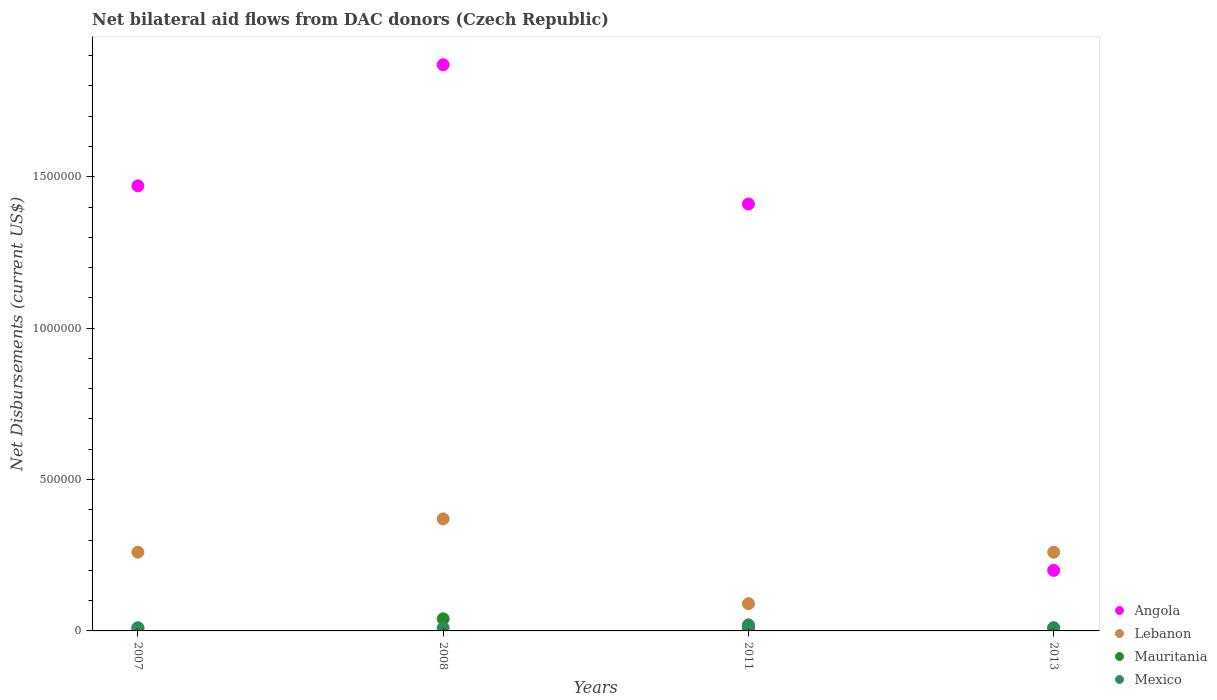Is the number of dotlines equal to the number of legend labels?
Your answer should be very brief. Yes. What is the net bilateral aid flows in Angola in 2008?
Ensure brevity in your answer.  1.87e+06. Across all years, what is the minimum net bilateral aid flows in Lebanon?
Your answer should be compact. 9.00e+04. In which year was the net bilateral aid flows in Mauritania maximum?
Offer a terse response. 2008. What is the total net bilateral aid flows in Lebanon in the graph?
Your answer should be compact. 9.80e+05. What is the difference between the net bilateral aid flows in Lebanon in 2007 and that in 2011?
Provide a short and direct response. 1.70e+05. What is the difference between the net bilateral aid flows in Mauritania in 2011 and the net bilateral aid flows in Lebanon in 2013?
Provide a succinct answer. -2.50e+05. What is the average net bilateral aid flows in Mexico per year?
Give a very brief answer. 1.25e+04. In the year 2008, what is the difference between the net bilateral aid flows in Angola and net bilateral aid flows in Lebanon?
Your answer should be compact. 1.50e+06. What is the ratio of the net bilateral aid flows in Lebanon in 2008 to that in 2013?
Offer a very short reply. 1.42. Is the net bilateral aid flows in Angola in 2007 less than that in 2008?
Make the answer very short. Yes. Is the difference between the net bilateral aid flows in Angola in 2008 and 2011 greater than the difference between the net bilateral aid flows in Lebanon in 2008 and 2011?
Give a very brief answer. Yes. What is the difference between the highest and the lowest net bilateral aid flows in Angola?
Give a very brief answer. 1.67e+06. In how many years, is the net bilateral aid flows in Mexico greater than the average net bilateral aid flows in Mexico taken over all years?
Offer a very short reply. 1. Is the net bilateral aid flows in Mexico strictly greater than the net bilateral aid flows in Mauritania over the years?
Make the answer very short. No. Where does the legend appear in the graph?
Make the answer very short. Bottom right. How are the legend labels stacked?
Give a very brief answer. Vertical. What is the title of the graph?
Provide a short and direct response. Net bilateral aid flows from DAC donors (Czech Republic). Does "Swaziland" appear as one of the legend labels in the graph?
Offer a terse response. No. What is the label or title of the Y-axis?
Offer a very short reply. Net Disbursements (current US$). What is the Net Disbursements (current US$) of Angola in 2007?
Provide a succinct answer. 1.47e+06. What is the Net Disbursements (current US$) in Lebanon in 2007?
Offer a very short reply. 2.60e+05. What is the Net Disbursements (current US$) in Mauritania in 2007?
Ensure brevity in your answer.  10000. What is the Net Disbursements (current US$) of Mexico in 2007?
Provide a short and direct response. 10000. What is the Net Disbursements (current US$) of Angola in 2008?
Offer a terse response. 1.87e+06. What is the Net Disbursements (current US$) in Mauritania in 2008?
Provide a short and direct response. 4.00e+04. What is the Net Disbursements (current US$) in Mexico in 2008?
Your answer should be compact. 10000. What is the Net Disbursements (current US$) of Angola in 2011?
Your response must be concise. 1.41e+06. What is the Net Disbursements (current US$) of Lebanon in 2011?
Give a very brief answer. 9.00e+04. What is the Net Disbursements (current US$) in Mexico in 2011?
Your answer should be compact. 2.00e+04. Across all years, what is the maximum Net Disbursements (current US$) of Angola?
Offer a terse response. 1.87e+06. Across all years, what is the maximum Net Disbursements (current US$) in Lebanon?
Your response must be concise. 3.70e+05. Across all years, what is the minimum Net Disbursements (current US$) in Lebanon?
Ensure brevity in your answer.  9.00e+04. Across all years, what is the minimum Net Disbursements (current US$) in Mauritania?
Your answer should be very brief. 10000. Across all years, what is the minimum Net Disbursements (current US$) in Mexico?
Your response must be concise. 10000. What is the total Net Disbursements (current US$) in Angola in the graph?
Provide a short and direct response. 4.95e+06. What is the total Net Disbursements (current US$) in Lebanon in the graph?
Your answer should be compact. 9.80e+05. What is the total Net Disbursements (current US$) in Mauritania in the graph?
Offer a terse response. 7.00e+04. What is the total Net Disbursements (current US$) in Mexico in the graph?
Your response must be concise. 5.00e+04. What is the difference between the Net Disbursements (current US$) of Angola in 2007 and that in 2008?
Your answer should be very brief. -4.00e+05. What is the difference between the Net Disbursements (current US$) in Lebanon in 2007 and that in 2008?
Your answer should be compact. -1.10e+05. What is the difference between the Net Disbursements (current US$) of Mexico in 2007 and that in 2011?
Provide a short and direct response. -10000. What is the difference between the Net Disbursements (current US$) of Angola in 2007 and that in 2013?
Your answer should be very brief. 1.27e+06. What is the difference between the Net Disbursements (current US$) of Lebanon in 2007 and that in 2013?
Ensure brevity in your answer.  0. What is the difference between the Net Disbursements (current US$) in Lebanon in 2008 and that in 2011?
Give a very brief answer. 2.80e+05. What is the difference between the Net Disbursements (current US$) of Mauritania in 2008 and that in 2011?
Offer a terse response. 3.00e+04. What is the difference between the Net Disbursements (current US$) of Angola in 2008 and that in 2013?
Offer a terse response. 1.67e+06. What is the difference between the Net Disbursements (current US$) of Mauritania in 2008 and that in 2013?
Give a very brief answer. 3.00e+04. What is the difference between the Net Disbursements (current US$) of Angola in 2011 and that in 2013?
Offer a terse response. 1.21e+06. What is the difference between the Net Disbursements (current US$) of Lebanon in 2011 and that in 2013?
Ensure brevity in your answer.  -1.70e+05. What is the difference between the Net Disbursements (current US$) in Mauritania in 2011 and that in 2013?
Offer a terse response. 0. What is the difference between the Net Disbursements (current US$) in Mexico in 2011 and that in 2013?
Keep it short and to the point. 10000. What is the difference between the Net Disbursements (current US$) in Angola in 2007 and the Net Disbursements (current US$) in Lebanon in 2008?
Provide a succinct answer. 1.10e+06. What is the difference between the Net Disbursements (current US$) of Angola in 2007 and the Net Disbursements (current US$) of Mauritania in 2008?
Your answer should be compact. 1.43e+06. What is the difference between the Net Disbursements (current US$) of Angola in 2007 and the Net Disbursements (current US$) of Mexico in 2008?
Your answer should be compact. 1.46e+06. What is the difference between the Net Disbursements (current US$) of Lebanon in 2007 and the Net Disbursements (current US$) of Mauritania in 2008?
Give a very brief answer. 2.20e+05. What is the difference between the Net Disbursements (current US$) in Lebanon in 2007 and the Net Disbursements (current US$) in Mexico in 2008?
Keep it short and to the point. 2.50e+05. What is the difference between the Net Disbursements (current US$) in Angola in 2007 and the Net Disbursements (current US$) in Lebanon in 2011?
Offer a terse response. 1.38e+06. What is the difference between the Net Disbursements (current US$) of Angola in 2007 and the Net Disbursements (current US$) of Mauritania in 2011?
Provide a succinct answer. 1.46e+06. What is the difference between the Net Disbursements (current US$) of Angola in 2007 and the Net Disbursements (current US$) of Mexico in 2011?
Your response must be concise. 1.45e+06. What is the difference between the Net Disbursements (current US$) of Lebanon in 2007 and the Net Disbursements (current US$) of Mauritania in 2011?
Provide a short and direct response. 2.50e+05. What is the difference between the Net Disbursements (current US$) of Lebanon in 2007 and the Net Disbursements (current US$) of Mexico in 2011?
Provide a succinct answer. 2.40e+05. What is the difference between the Net Disbursements (current US$) of Angola in 2007 and the Net Disbursements (current US$) of Lebanon in 2013?
Your answer should be compact. 1.21e+06. What is the difference between the Net Disbursements (current US$) in Angola in 2007 and the Net Disbursements (current US$) in Mauritania in 2013?
Provide a succinct answer. 1.46e+06. What is the difference between the Net Disbursements (current US$) of Angola in 2007 and the Net Disbursements (current US$) of Mexico in 2013?
Offer a terse response. 1.46e+06. What is the difference between the Net Disbursements (current US$) in Lebanon in 2007 and the Net Disbursements (current US$) in Mauritania in 2013?
Provide a short and direct response. 2.50e+05. What is the difference between the Net Disbursements (current US$) in Lebanon in 2007 and the Net Disbursements (current US$) in Mexico in 2013?
Keep it short and to the point. 2.50e+05. What is the difference between the Net Disbursements (current US$) of Mauritania in 2007 and the Net Disbursements (current US$) of Mexico in 2013?
Your answer should be very brief. 0. What is the difference between the Net Disbursements (current US$) in Angola in 2008 and the Net Disbursements (current US$) in Lebanon in 2011?
Your response must be concise. 1.78e+06. What is the difference between the Net Disbursements (current US$) of Angola in 2008 and the Net Disbursements (current US$) of Mauritania in 2011?
Offer a very short reply. 1.86e+06. What is the difference between the Net Disbursements (current US$) of Angola in 2008 and the Net Disbursements (current US$) of Mexico in 2011?
Your answer should be compact. 1.85e+06. What is the difference between the Net Disbursements (current US$) of Lebanon in 2008 and the Net Disbursements (current US$) of Mexico in 2011?
Offer a terse response. 3.50e+05. What is the difference between the Net Disbursements (current US$) of Mauritania in 2008 and the Net Disbursements (current US$) of Mexico in 2011?
Ensure brevity in your answer.  2.00e+04. What is the difference between the Net Disbursements (current US$) of Angola in 2008 and the Net Disbursements (current US$) of Lebanon in 2013?
Your answer should be very brief. 1.61e+06. What is the difference between the Net Disbursements (current US$) of Angola in 2008 and the Net Disbursements (current US$) of Mauritania in 2013?
Ensure brevity in your answer.  1.86e+06. What is the difference between the Net Disbursements (current US$) of Angola in 2008 and the Net Disbursements (current US$) of Mexico in 2013?
Give a very brief answer. 1.86e+06. What is the difference between the Net Disbursements (current US$) of Lebanon in 2008 and the Net Disbursements (current US$) of Mexico in 2013?
Make the answer very short. 3.60e+05. What is the difference between the Net Disbursements (current US$) of Mauritania in 2008 and the Net Disbursements (current US$) of Mexico in 2013?
Make the answer very short. 3.00e+04. What is the difference between the Net Disbursements (current US$) of Angola in 2011 and the Net Disbursements (current US$) of Lebanon in 2013?
Offer a very short reply. 1.15e+06. What is the difference between the Net Disbursements (current US$) in Angola in 2011 and the Net Disbursements (current US$) in Mauritania in 2013?
Your response must be concise. 1.40e+06. What is the difference between the Net Disbursements (current US$) in Angola in 2011 and the Net Disbursements (current US$) in Mexico in 2013?
Provide a short and direct response. 1.40e+06. What is the difference between the Net Disbursements (current US$) in Lebanon in 2011 and the Net Disbursements (current US$) in Mauritania in 2013?
Offer a terse response. 8.00e+04. What is the difference between the Net Disbursements (current US$) of Lebanon in 2011 and the Net Disbursements (current US$) of Mexico in 2013?
Give a very brief answer. 8.00e+04. What is the average Net Disbursements (current US$) in Angola per year?
Your answer should be compact. 1.24e+06. What is the average Net Disbursements (current US$) in Lebanon per year?
Provide a short and direct response. 2.45e+05. What is the average Net Disbursements (current US$) in Mauritania per year?
Your response must be concise. 1.75e+04. What is the average Net Disbursements (current US$) of Mexico per year?
Your response must be concise. 1.25e+04. In the year 2007, what is the difference between the Net Disbursements (current US$) of Angola and Net Disbursements (current US$) of Lebanon?
Your answer should be very brief. 1.21e+06. In the year 2007, what is the difference between the Net Disbursements (current US$) in Angola and Net Disbursements (current US$) in Mauritania?
Offer a very short reply. 1.46e+06. In the year 2007, what is the difference between the Net Disbursements (current US$) of Angola and Net Disbursements (current US$) of Mexico?
Keep it short and to the point. 1.46e+06. In the year 2007, what is the difference between the Net Disbursements (current US$) in Mauritania and Net Disbursements (current US$) in Mexico?
Keep it short and to the point. 0. In the year 2008, what is the difference between the Net Disbursements (current US$) in Angola and Net Disbursements (current US$) in Lebanon?
Your answer should be compact. 1.50e+06. In the year 2008, what is the difference between the Net Disbursements (current US$) of Angola and Net Disbursements (current US$) of Mauritania?
Give a very brief answer. 1.83e+06. In the year 2008, what is the difference between the Net Disbursements (current US$) in Angola and Net Disbursements (current US$) in Mexico?
Ensure brevity in your answer.  1.86e+06. In the year 2011, what is the difference between the Net Disbursements (current US$) in Angola and Net Disbursements (current US$) in Lebanon?
Your answer should be compact. 1.32e+06. In the year 2011, what is the difference between the Net Disbursements (current US$) in Angola and Net Disbursements (current US$) in Mauritania?
Offer a terse response. 1.40e+06. In the year 2011, what is the difference between the Net Disbursements (current US$) of Angola and Net Disbursements (current US$) of Mexico?
Your response must be concise. 1.39e+06. In the year 2011, what is the difference between the Net Disbursements (current US$) of Lebanon and Net Disbursements (current US$) of Mauritania?
Make the answer very short. 8.00e+04. In the year 2011, what is the difference between the Net Disbursements (current US$) in Lebanon and Net Disbursements (current US$) in Mexico?
Your response must be concise. 7.00e+04. In the year 2013, what is the difference between the Net Disbursements (current US$) in Lebanon and Net Disbursements (current US$) in Mauritania?
Provide a short and direct response. 2.50e+05. In the year 2013, what is the difference between the Net Disbursements (current US$) in Mauritania and Net Disbursements (current US$) in Mexico?
Offer a terse response. 0. What is the ratio of the Net Disbursements (current US$) of Angola in 2007 to that in 2008?
Ensure brevity in your answer.  0.79. What is the ratio of the Net Disbursements (current US$) of Lebanon in 2007 to that in 2008?
Provide a succinct answer. 0.7. What is the ratio of the Net Disbursements (current US$) of Mauritania in 2007 to that in 2008?
Give a very brief answer. 0.25. What is the ratio of the Net Disbursements (current US$) in Angola in 2007 to that in 2011?
Your answer should be compact. 1.04. What is the ratio of the Net Disbursements (current US$) in Lebanon in 2007 to that in 2011?
Offer a terse response. 2.89. What is the ratio of the Net Disbursements (current US$) in Mauritania in 2007 to that in 2011?
Offer a very short reply. 1. What is the ratio of the Net Disbursements (current US$) in Angola in 2007 to that in 2013?
Your response must be concise. 7.35. What is the ratio of the Net Disbursements (current US$) of Lebanon in 2007 to that in 2013?
Your answer should be very brief. 1. What is the ratio of the Net Disbursements (current US$) in Mexico in 2007 to that in 2013?
Your response must be concise. 1. What is the ratio of the Net Disbursements (current US$) in Angola in 2008 to that in 2011?
Make the answer very short. 1.33. What is the ratio of the Net Disbursements (current US$) in Lebanon in 2008 to that in 2011?
Provide a short and direct response. 4.11. What is the ratio of the Net Disbursements (current US$) in Mauritania in 2008 to that in 2011?
Provide a short and direct response. 4. What is the ratio of the Net Disbursements (current US$) of Mexico in 2008 to that in 2011?
Offer a very short reply. 0.5. What is the ratio of the Net Disbursements (current US$) of Angola in 2008 to that in 2013?
Offer a terse response. 9.35. What is the ratio of the Net Disbursements (current US$) of Lebanon in 2008 to that in 2013?
Give a very brief answer. 1.42. What is the ratio of the Net Disbursements (current US$) in Angola in 2011 to that in 2013?
Keep it short and to the point. 7.05. What is the ratio of the Net Disbursements (current US$) in Lebanon in 2011 to that in 2013?
Make the answer very short. 0.35. What is the difference between the highest and the second highest Net Disbursements (current US$) of Angola?
Give a very brief answer. 4.00e+05. What is the difference between the highest and the second highest Net Disbursements (current US$) of Lebanon?
Offer a very short reply. 1.10e+05. What is the difference between the highest and the lowest Net Disbursements (current US$) in Angola?
Give a very brief answer. 1.67e+06. What is the difference between the highest and the lowest Net Disbursements (current US$) of Lebanon?
Offer a very short reply. 2.80e+05. What is the difference between the highest and the lowest Net Disbursements (current US$) in Mauritania?
Give a very brief answer. 3.00e+04. 